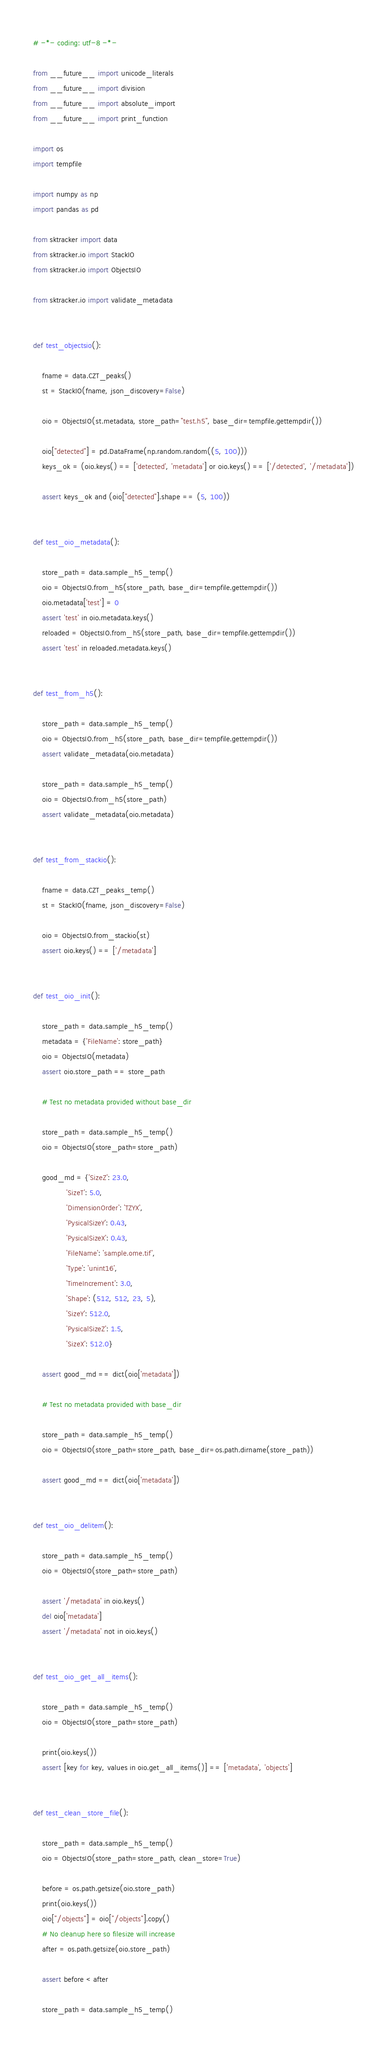Convert code to text. <code><loc_0><loc_0><loc_500><loc_500><_Python_># -*- coding: utf-8 -*-

from __future__ import unicode_literals
from __future__ import division
from __future__ import absolute_import
from __future__ import print_function

import os
import tempfile

import numpy as np
import pandas as pd

from sktracker import data
from sktracker.io import StackIO
from sktracker.io import ObjectsIO

from sktracker.io import validate_metadata


def test_objectsio():

    fname = data.CZT_peaks()
    st = StackIO(fname, json_discovery=False)

    oio = ObjectsIO(st.metadata, store_path="test.h5", base_dir=tempfile.gettempdir())

    oio["detected"] = pd.DataFrame(np.random.random((5, 100)))
    keys_ok = (oio.keys() == ['detected', 'metadata'] or oio.keys() == ['/detected', '/metadata'])

    assert keys_ok and (oio["detected"].shape == (5, 100))


def test_oio_metadata():

    store_path = data.sample_h5_temp()
    oio = ObjectsIO.from_h5(store_path, base_dir=tempfile.gettempdir())
    oio.metadata['test'] = 0
    assert 'test' in oio.metadata.keys()
    reloaded = ObjectsIO.from_h5(store_path, base_dir=tempfile.gettempdir())
    assert 'test' in reloaded.metadata.keys()


def test_from_h5():

    store_path = data.sample_h5_temp()
    oio = ObjectsIO.from_h5(store_path, base_dir=tempfile.gettempdir())
    assert validate_metadata(oio.metadata)

    store_path = data.sample_h5_temp()
    oio = ObjectsIO.from_h5(store_path)
    assert validate_metadata(oio.metadata)


def test_from_stackio():

    fname = data.CZT_peaks_temp()
    st = StackIO(fname, json_discovery=False)

    oio = ObjectsIO.from_stackio(st)
    assert oio.keys() == ['/metadata']


def test_oio_init():

    store_path = data.sample_h5_temp()
    metadata = {'FileName': store_path}
    oio = ObjectsIO(metadata)
    assert oio.store_path == store_path

    # Test no metadata provided without base_dir

    store_path = data.sample_h5_temp()
    oio = ObjectsIO(store_path=store_path)

    good_md = {'SizeZ': 23.0,
               'SizeT': 5.0,
               'DimensionOrder': 'TZYX',
               'PysicalSizeY': 0.43,
               'PysicalSizeX': 0.43,
               'FileName': 'sample.ome.tif',
               'Type': 'unint16',
               'TimeIncrement': 3.0,
               'Shape': (512, 512, 23, 5),
               'SizeY': 512.0,
               'PysicalSizeZ': 1.5,
               'SizeX': 512.0}

    assert good_md == dict(oio['metadata'])

    # Test no metadata provided with base_dir

    store_path = data.sample_h5_temp()
    oio = ObjectsIO(store_path=store_path, base_dir=os.path.dirname(store_path))

    assert good_md == dict(oio['metadata'])


def test_oio_delitem():

    store_path = data.sample_h5_temp()
    oio = ObjectsIO(store_path=store_path)

    assert '/metadata' in oio.keys()
    del oio['metadata']
    assert '/metadata' not in oio.keys()


def test_oio_get_all_items():

    store_path = data.sample_h5_temp()
    oio = ObjectsIO(store_path=store_path)

    print(oio.keys())
    assert [key for key, values in oio.get_all_items()] == ['metadata', 'objects']


def test_clean_store_file():

    store_path = data.sample_h5_temp()
    oio = ObjectsIO(store_path=store_path, clean_store=True)

    before = os.path.getsize(oio.store_path)
    print(oio.keys())
    oio["/objects"] = oio["/objects"].copy()
    # No cleanup here so filesize will increase
    after = os.path.getsize(oio.store_path)

    assert before < after

    store_path = data.sample_h5_temp()</code> 